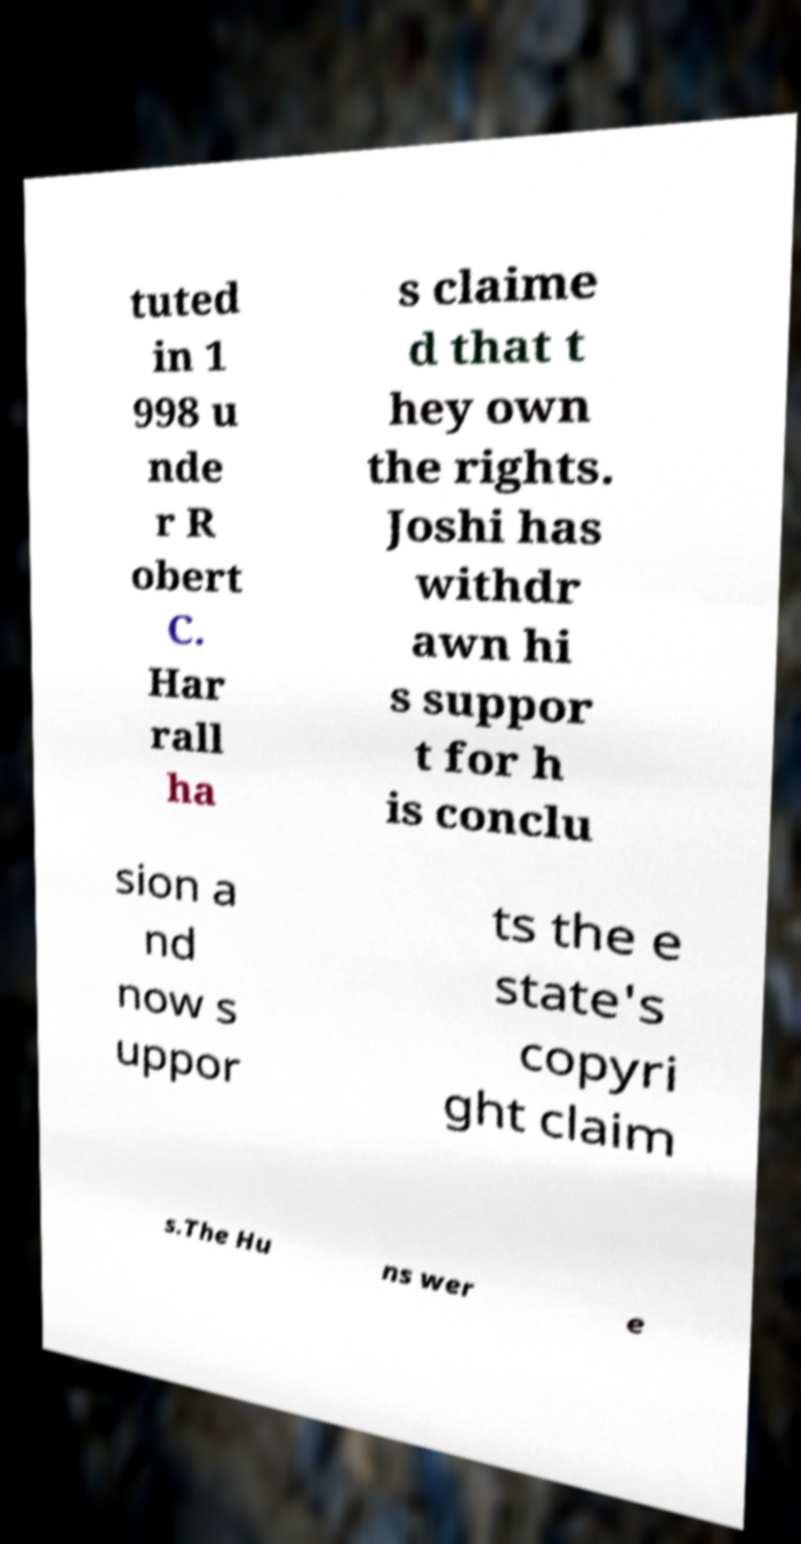For documentation purposes, I need the text within this image transcribed. Could you provide that? tuted in 1 998 u nde r R obert C. Har rall ha s claime d that t hey own the rights. Joshi has withdr awn hi s suppor t for h is conclu sion a nd now s uppor ts the e state's copyri ght claim s.The Hu ns wer e 